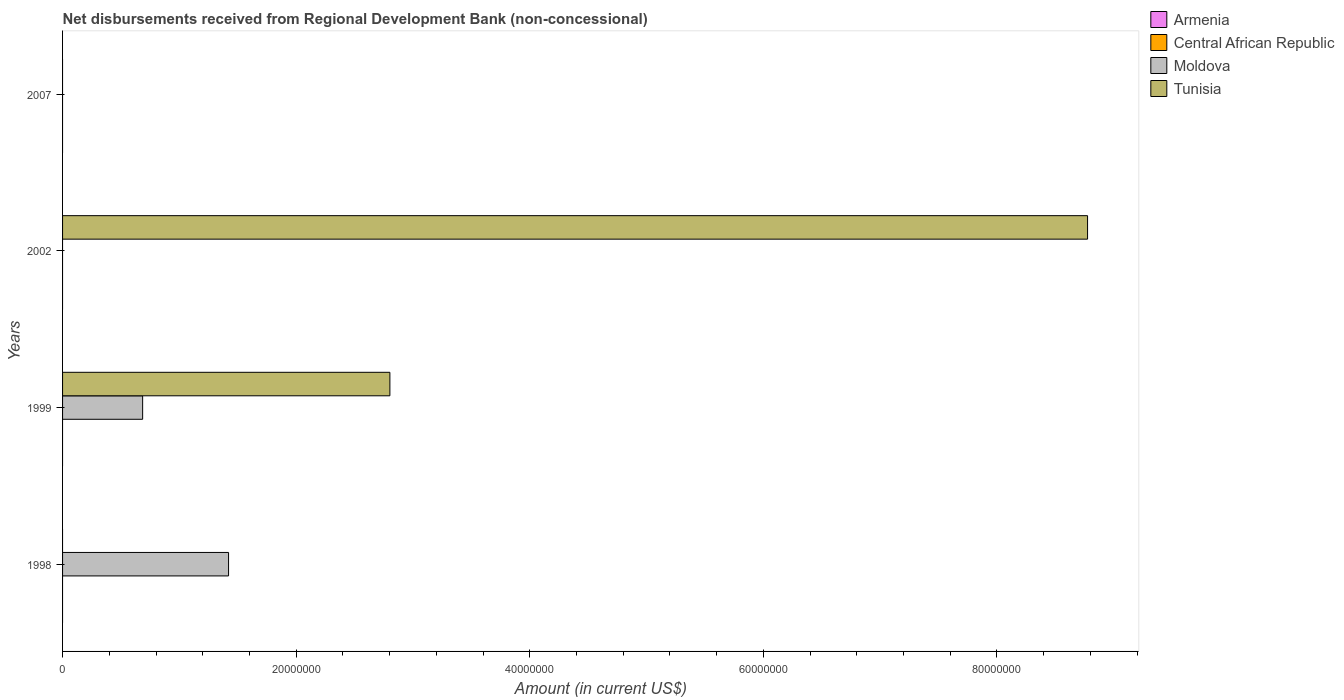How many different coloured bars are there?
Your answer should be compact. 2. What is the label of the 1st group of bars from the top?
Your answer should be very brief. 2007. In how many cases, is the number of bars for a given year not equal to the number of legend labels?
Provide a short and direct response. 4. Across all years, what is the maximum amount of disbursements received from Regional Development Bank in Tunisia?
Provide a succinct answer. 8.78e+07. Across all years, what is the minimum amount of disbursements received from Regional Development Bank in Moldova?
Make the answer very short. 0. What is the difference between the amount of disbursements received from Regional Development Bank in Tunisia in 1999 and that in 2002?
Provide a succinct answer. -5.97e+07. What is the difference between the amount of disbursements received from Regional Development Bank in Central African Republic in 1998 and the amount of disbursements received from Regional Development Bank in Tunisia in 2002?
Offer a terse response. -8.78e+07. What is the average amount of disbursements received from Regional Development Bank in Tunisia per year?
Offer a very short reply. 2.89e+07. In how many years, is the amount of disbursements received from Regional Development Bank in Tunisia greater than 4000000 US$?
Ensure brevity in your answer.  2. What is the ratio of the amount of disbursements received from Regional Development Bank in Moldova in 1998 to that in 1999?
Your answer should be compact. 2.07. What is the difference between the highest and the lowest amount of disbursements received from Regional Development Bank in Moldova?
Your answer should be compact. 1.42e+07. In how many years, is the amount of disbursements received from Regional Development Bank in Armenia greater than the average amount of disbursements received from Regional Development Bank in Armenia taken over all years?
Your answer should be very brief. 0. Is it the case that in every year, the sum of the amount of disbursements received from Regional Development Bank in Central African Republic and amount of disbursements received from Regional Development Bank in Tunisia is greater than the sum of amount of disbursements received from Regional Development Bank in Armenia and amount of disbursements received from Regional Development Bank in Moldova?
Provide a succinct answer. No. Is it the case that in every year, the sum of the amount of disbursements received from Regional Development Bank in Central African Republic and amount of disbursements received from Regional Development Bank in Moldova is greater than the amount of disbursements received from Regional Development Bank in Tunisia?
Keep it short and to the point. No. How many bars are there?
Your response must be concise. 4. Are all the bars in the graph horizontal?
Provide a short and direct response. Yes. How many years are there in the graph?
Provide a short and direct response. 4. What is the difference between two consecutive major ticks on the X-axis?
Provide a short and direct response. 2.00e+07. Are the values on the major ticks of X-axis written in scientific E-notation?
Your response must be concise. No. Does the graph contain any zero values?
Offer a terse response. Yes. Where does the legend appear in the graph?
Ensure brevity in your answer.  Top right. How many legend labels are there?
Ensure brevity in your answer.  4. What is the title of the graph?
Keep it short and to the point. Net disbursements received from Regional Development Bank (non-concessional). Does "Bermuda" appear as one of the legend labels in the graph?
Your response must be concise. No. What is the label or title of the Y-axis?
Provide a succinct answer. Years. What is the Amount (in current US$) in Armenia in 1998?
Your response must be concise. 0. What is the Amount (in current US$) in Central African Republic in 1998?
Offer a terse response. 0. What is the Amount (in current US$) in Moldova in 1998?
Your answer should be compact. 1.42e+07. What is the Amount (in current US$) of Central African Republic in 1999?
Ensure brevity in your answer.  0. What is the Amount (in current US$) in Moldova in 1999?
Make the answer very short. 6.86e+06. What is the Amount (in current US$) of Tunisia in 1999?
Keep it short and to the point. 2.80e+07. What is the Amount (in current US$) of Tunisia in 2002?
Ensure brevity in your answer.  8.78e+07. What is the Amount (in current US$) in Armenia in 2007?
Ensure brevity in your answer.  0. What is the Amount (in current US$) of Central African Republic in 2007?
Make the answer very short. 0. Across all years, what is the maximum Amount (in current US$) in Moldova?
Your response must be concise. 1.42e+07. Across all years, what is the maximum Amount (in current US$) of Tunisia?
Offer a terse response. 8.78e+07. Across all years, what is the minimum Amount (in current US$) of Moldova?
Your response must be concise. 0. What is the total Amount (in current US$) in Central African Republic in the graph?
Your response must be concise. 0. What is the total Amount (in current US$) of Moldova in the graph?
Provide a succinct answer. 2.11e+07. What is the total Amount (in current US$) in Tunisia in the graph?
Ensure brevity in your answer.  1.16e+08. What is the difference between the Amount (in current US$) of Moldova in 1998 and that in 1999?
Offer a very short reply. 7.36e+06. What is the difference between the Amount (in current US$) of Tunisia in 1999 and that in 2002?
Give a very brief answer. -5.97e+07. What is the difference between the Amount (in current US$) in Moldova in 1998 and the Amount (in current US$) in Tunisia in 1999?
Your response must be concise. -1.38e+07. What is the difference between the Amount (in current US$) in Moldova in 1998 and the Amount (in current US$) in Tunisia in 2002?
Your answer should be compact. -7.35e+07. What is the difference between the Amount (in current US$) of Moldova in 1999 and the Amount (in current US$) of Tunisia in 2002?
Offer a very short reply. -8.09e+07. What is the average Amount (in current US$) in Moldova per year?
Give a very brief answer. 5.27e+06. What is the average Amount (in current US$) of Tunisia per year?
Your answer should be very brief. 2.89e+07. In the year 1999, what is the difference between the Amount (in current US$) in Moldova and Amount (in current US$) in Tunisia?
Give a very brief answer. -2.12e+07. What is the ratio of the Amount (in current US$) of Moldova in 1998 to that in 1999?
Keep it short and to the point. 2.07. What is the ratio of the Amount (in current US$) of Tunisia in 1999 to that in 2002?
Provide a succinct answer. 0.32. What is the difference between the highest and the lowest Amount (in current US$) in Moldova?
Your answer should be compact. 1.42e+07. What is the difference between the highest and the lowest Amount (in current US$) in Tunisia?
Ensure brevity in your answer.  8.78e+07. 